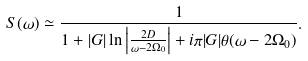<formula> <loc_0><loc_0><loc_500><loc_500>S ( \omega ) \simeq \frac { 1 } { 1 + | G | \ln \left | \frac { 2 D } { \omega - 2 \Omega _ { 0 } } \right | + i \pi | G | \theta ( \omega - 2 \Omega _ { 0 } ) } .</formula> 